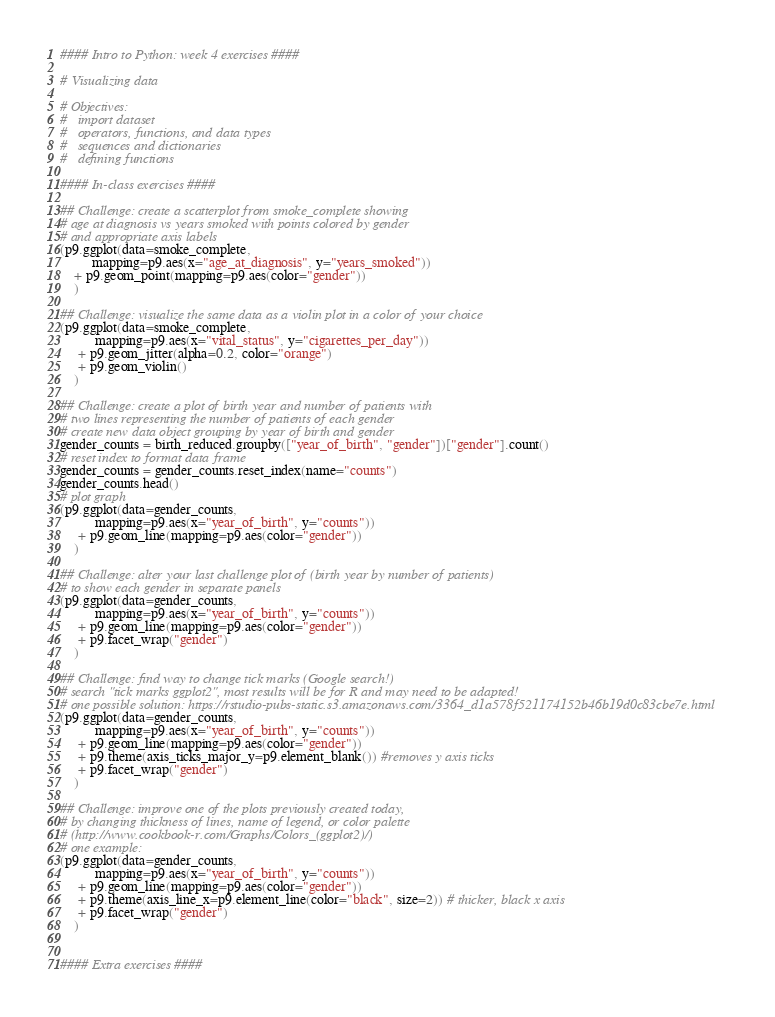<code> <loc_0><loc_0><loc_500><loc_500><_Python_>#### Intro to Python: week 4 exercises ####

# Visualizing data

# Objectives:
#   import dataset
#   operators, functions, and data types
#   sequences and dictionaries
#   defining functions

#### In-class exercises ####

## Challenge: create a scatterplot from smoke_complete showing
# age at diagnosis vs years smoked with points colored by gender
# and appropriate axis labels
(p9.ggplot(data=smoke_complete,
         mapping=p9.aes(x="age_at_diagnosis", y="years_smoked"))
    + p9.geom_point(mapping=p9.aes(color="gender"))
    )

## Challenge: visualize the same data as a violin plot in a color of your choice
(p9.ggplot(data=smoke_complete,
          mapping=p9.aes(x="vital_status", y="cigarettes_per_day"))
     + p9.geom_jitter(alpha=0.2, color="orange")
     + p9.geom_violin()
    )

## Challenge: create a plot of birth year and number of patients with
# two lines representing the number of patients of each gender
# create new data object grouping by year of birth and gender
gender_counts = birth_reduced.groupby(["year_of_birth", "gender"])["gender"].count()
# reset index to format data frame
gender_counts = gender_counts.reset_index(name="counts")
gender_counts.head()
# plot graph
(p9.ggplot(data=gender_counts,
          mapping=p9.aes(x="year_of_birth", y="counts"))
     + p9.geom_line(mapping=p9.aes(color="gender"))
    )

## Challenge: alter your last challenge plot of (birth year by number of patients)
# to show each gender in separate panels
(p9.ggplot(data=gender_counts,
          mapping=p9.aes(x="year_of_birth", y="counts"))
     + p9.geom_line(mapping=p9.aes(color="gender"))
     + p9.facet_wrap("gender")
    )

## Challenge: find way to change tick marks (Google search!)
# search "tick marks ggplot2", most results will be for R and may need to be adapted!
# one possible solution: https://rstudio-pubs-static.s3.amazonaws.com/3364_d1a578f521174152b46b19d0c83cbe7e.html
(p9.ggplot(data=gender_counts,
          mapping=p9.aes(x="year_of_birth", y="counts"))
     + p9.geom_line(mapping=p9.aes(color="gender"))
     + p9.theme(axis_ticks_major_y=p9.element_blank()) #removes y axis ticks
     + p9.facet_wrap("gender")
    )

## Challenge: improve one of the plots previously created today,
# by changing thickness of lines, name of legend, or color palette
# (http://www.cookbook-r.com/Graphs/Colors_(ggplot2)/)
# one example:
(p9.ggplot(data=gender_counts,
          mapping=p9.aes(x="year_of_birth", y="counts"))
     + p9.geom_line(mapping=p9.aes(color="gender"))
     + p9.theme(axis_line_x=p9.element_line(color="black", size=2)) # thicker, black x axis
     + p9.facet_wrap("gender")
    )


#### Extra exercises ####
</code> 